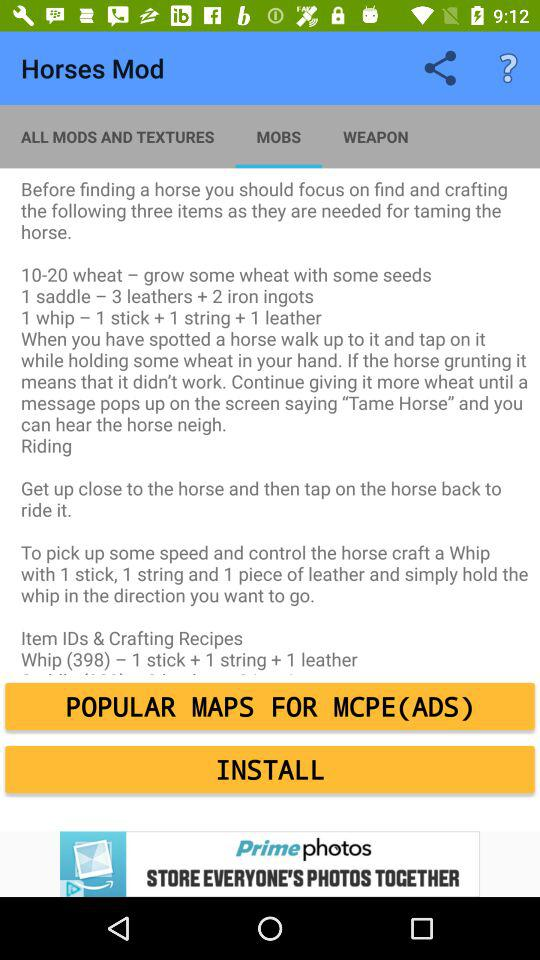How many leathers do you need to craft a saddle and a whip?
Answer the question using a single word or phrase. 4 